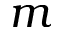<formula> <loc_0><loc_0><loc_500><loc_500>m</formula> 